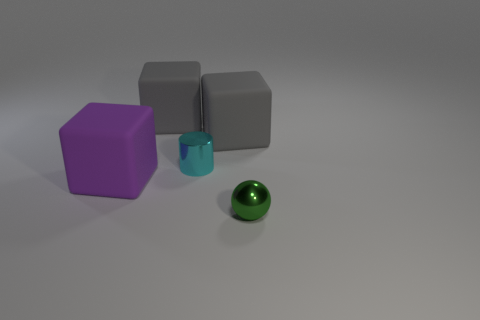Add 3 small green things. How many objects exist? 8 Subtract all balls. How many objects are left? 4 Subtract all big cyan metallic spheres. Subtract all green things. How many objects are left? 4 Add 5 tiny cyan objects. How many tiny cyan objects are left? 6 Add 3 metal spheres. How many metal spheres exist? 4 Subtract 0 yellow cylinders. How many objects are left? 5 